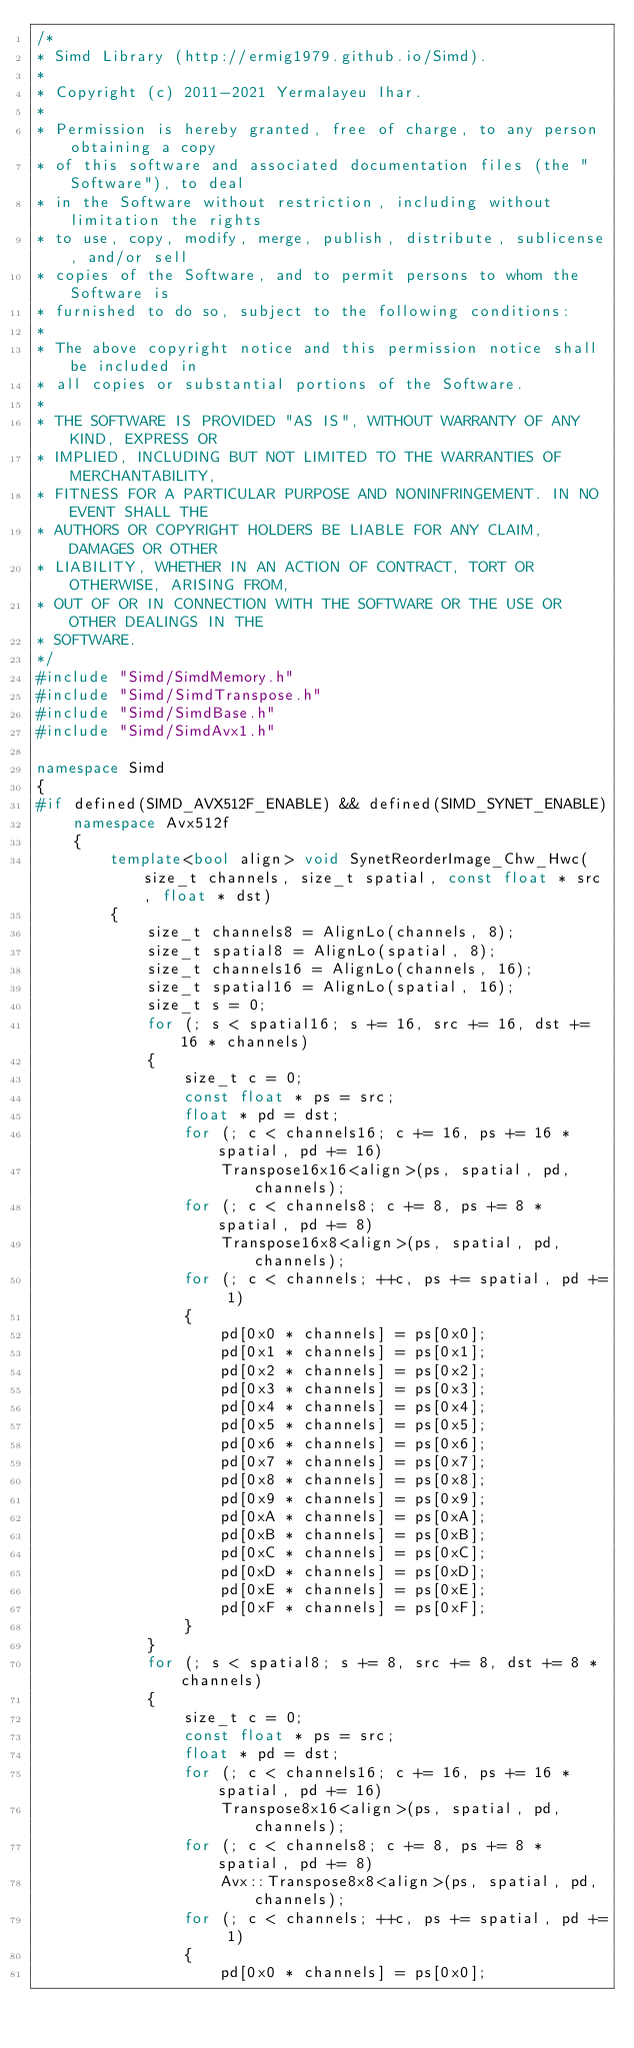Convert code to text. <code><loc_0><loc_0><loc_500><loc_500><_C++_>/*
* Simd Library (http://ermig1979.github.io/Simd).
*
* Copyright (c) 2011-2021 Yermalayeu Ihar.
*
* Permission is hereby granted, free of charge, to any person obtaining a copy
* of this software and associated documentation files (the "Software"), to deal
* in the Software without restriction, including without limitation the rights
* to use, copy, modify, merge, publish, distribute, sublicense, and/or sell
* copies of the Software, and to permit persons to whom the Software is
* furnished to do so, subject to the following conditions:
*
* The above copyright notice and this permission notice shall be included in
* all copies or substantial portions of the Software.
*
* THE SOFTWARE IS PROVIDED "AS IS", WITHOUT WARRANTY OF ANY KIND, EXPRESS OR
* IMPLIED, INCLUDING BUT NOT LIMITED TO THE WARRANTIES OF MERCHANTABILITY,
* FITNESS FOR A PARTICULAR PURPOSE AND NONINFRINGEMENT. IN NO EVENT SHALL THE
* AUTHORS OR COPYRIGHT HOLDERS BE LIABLE FOR ANY CLAIM, DAMAGES OR OTHER
* LIABILITY, WHETHER IN AN ACTION OF CONTRACT, TORT OR OTHERWISE, ARISING FROM,
* OUT OF OR IN CONNECTION WITH THE SOFTWARE OR THE USE OR OTHER DEALINGS IN THE
* SOFTWARE.
*/
#include "Simd/SimdMemory.h"
#include "Simd/SimdTranspose.h"
#include "Simd/SimdBase.h"
#include "Simd/SimdAvx1.h"

namespace Simd
{
#if defined(SIMD_AVX512F_ENABLE) && defined(SIMD_SYNET_ENABLE)   
    namespace Avx512f
    {
        template<bool align> void SynetReorderImage_Chw_Hwc(size_t channels, size_t spatial, const float * src, float * dst)
        {
            size_t channels8 = AlignLo(channels, 8);
            size_t spatial8 = AlignLo(spatial, 8);
            size_t channels16 = AlignLo(channels, 16);
            size_t spatial16 = AlignLo(spatial, 16);
            size_t s = 0;
            for (; s < spatial16; s += 16, src += 16, dst += 16 * channels)
            {
                size_t c = 0;
                const float * ps = src;
                float * pd = dst;
                for (; c < channels16; c += 16, ps += 16 * spatial, pd += 16)
                    Transpose16x16<align>(ps, spatial, pd, channels);
                for (; c < channels8; c += 8, ps += 8 * spatial, pd += 8)
                    Transpose16x8<align>(ps, spatial, pd, channels);
                for (; c < channels; ++c, ps += spatial, pd += 1)
                {
                    pd[0x0 * channels] = ps[0x0];
                    pd[0x1 * channels] = ps[0x1];
                    pd[0x2 * channels] = ps[0x2];
                    pd[0x3 * channels] = ps[0x3];
                    pd[0x4 * channels] = ps[0x4];
                    pd[0x5 * channels] = ps[0x5];
                    pd[0x6 * channels] = ps[0x6];
                    pd[0x7 * channels] = ps[0x7];
                    pd[0x8 * channels] = ps[0x8];
                    pd[0x9 * channels] = ps[0x9];
                    pd[0xA * channels] = ps[0xA];
                    pd[0xB * channels] = ps[0xB];
                    pd[0xC * channels] = ps[0xC];
                    pd[0xD * channels] = ps[0xD];
                    pd[0xE * channels] = ps[0xE];
                    pd[0xF * channels] = ps[0xF];
                }
            }
            for (; s < spatial8; s += 8, src += 8, dst += 8 * channels)
            {
                size_t c = 0;
                const float * ps = src;
                float * pd = dst;
                for (; c < channels16; c += 16, ps += 16 * spatial, pd += 16)
                    Transpose8x16<align>(ps, spatial, pd, channels);
                for (; c < channels8; c += 8, ps += 8 * spatial, pd += 8)
                    Avx::Transpose8x8<align>(ps, spatial, pd, channels);
                for (; c < channels; ++c, ps += spatial, pd += 1)
                {
                    pd[0x0 * channels] = ps[0x0];</code> 